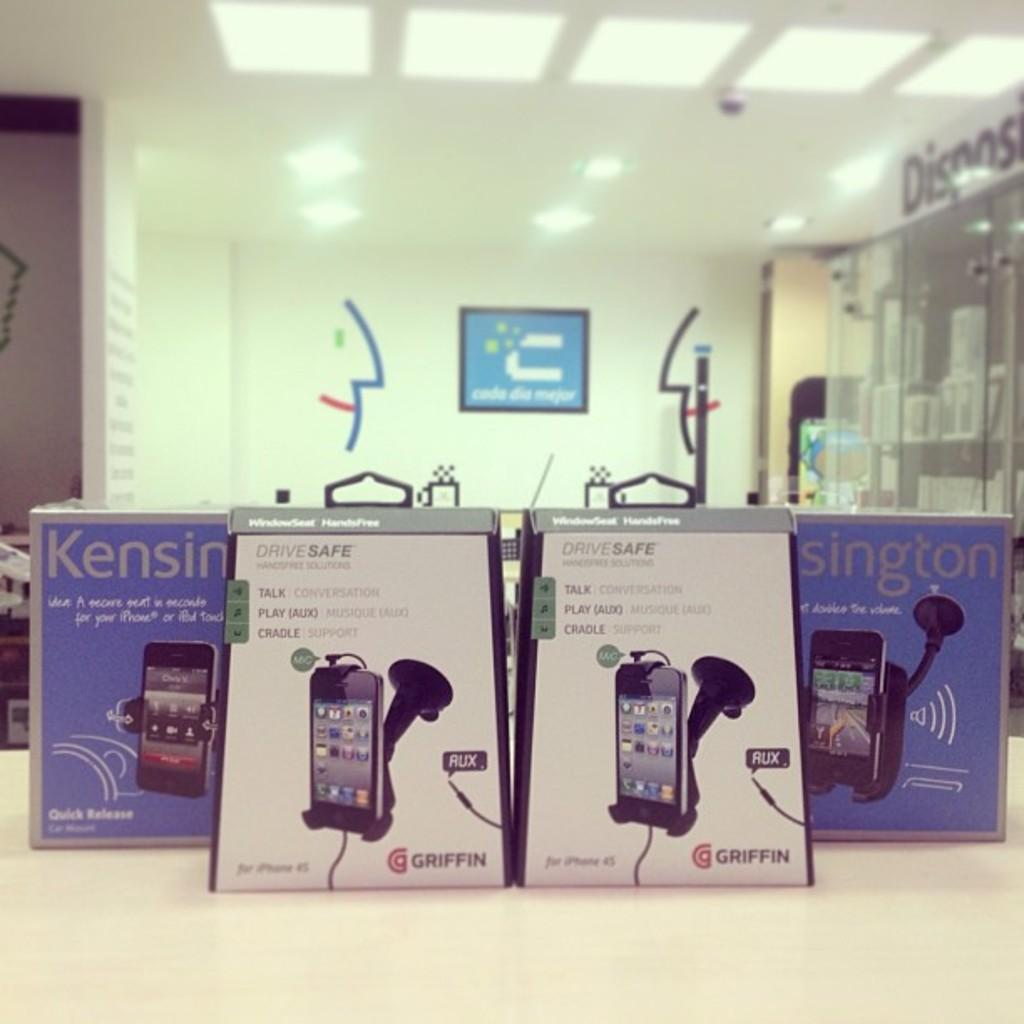<image>
Present a compact description of the photo's key features. 4 boxes of Kensington smart phone holders on display. 